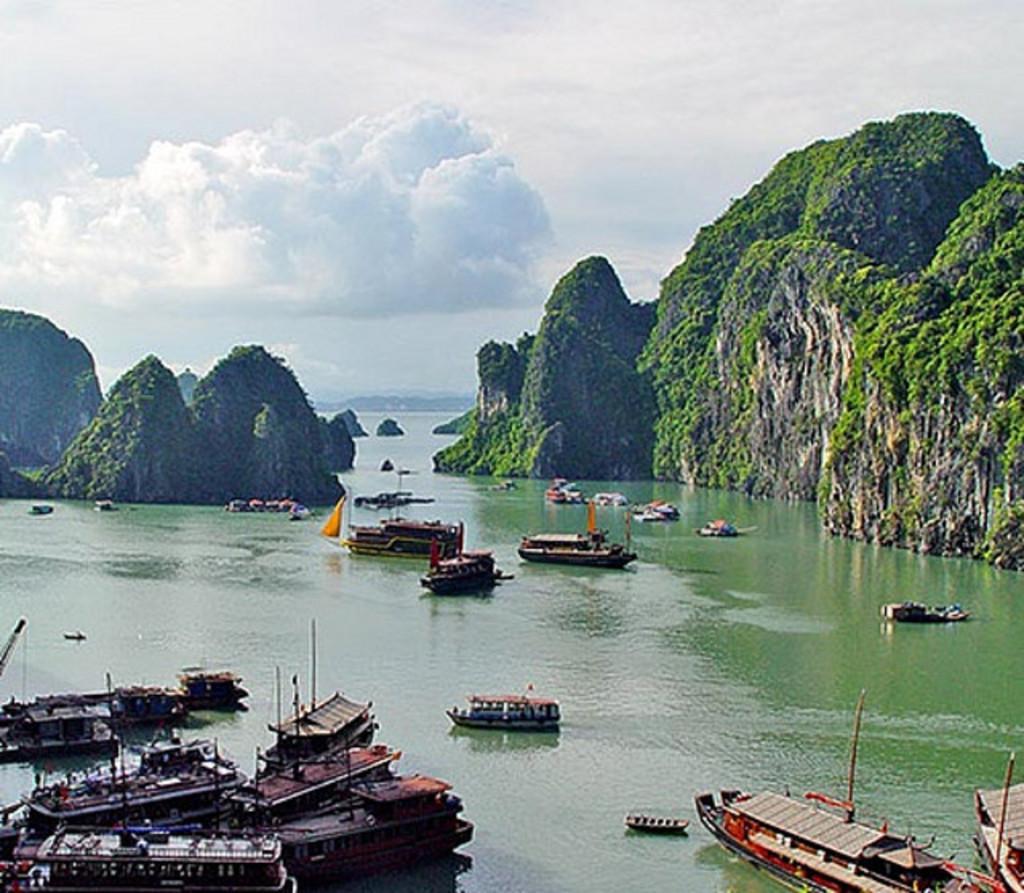Please provide a concise description of this image. In this image few boats are sailing on the surface of the water. Background there are hills. Top of the image three is sky with some clouds. 